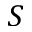<formula> <loc_0><loc_0><loc_500><loc_500>S</formula> 